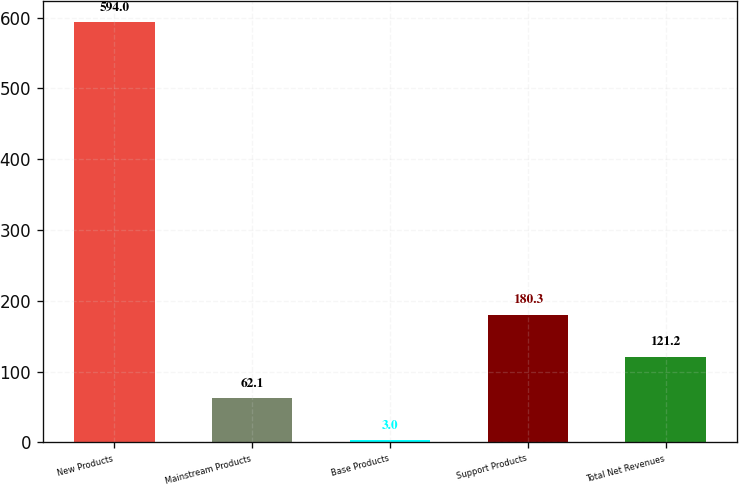Convert chart. <chart><loc_0><loc_0><loc_500><loc_500><bar_chart><fcel>New Products<fcel>Mainstream Products<fcel>Base Products<fcel>Support Products<fcel>Total Net Revenues<nl><fcel>594<fcel>62.1<fcel>3<fcel>180.3<fcel>121.2<nl></chart> 